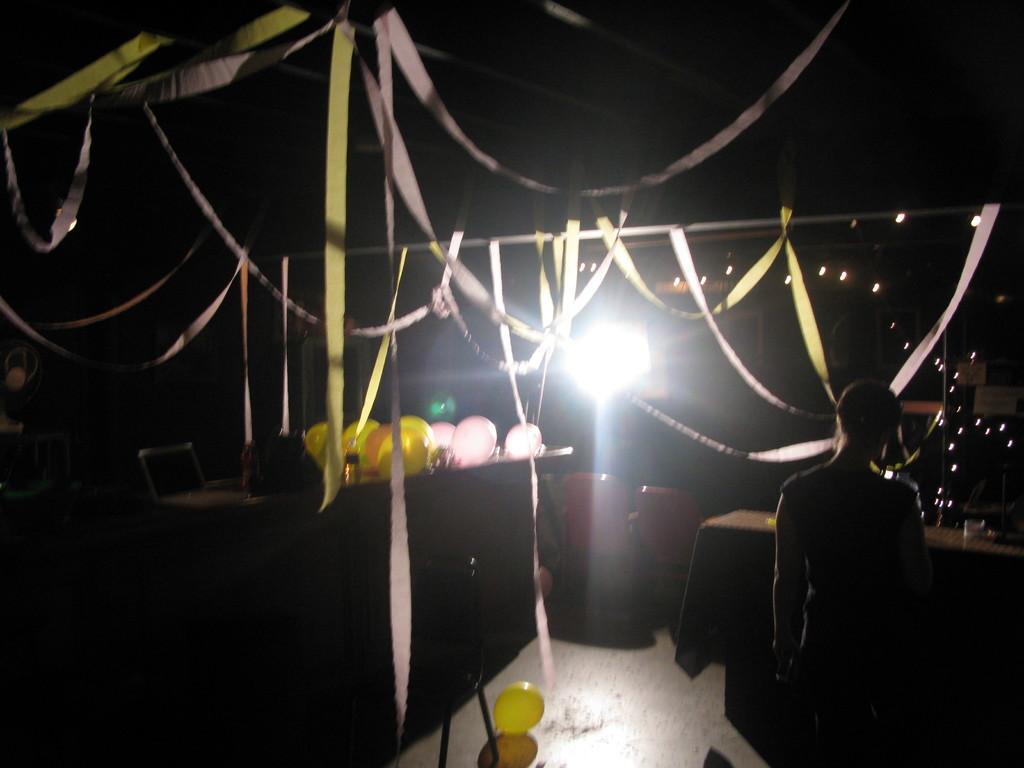Describe this image in one or two sentences. In this image there is a person and we can see balloons. There are chairs. At the top we can see decors and there are lights. There is a table. 